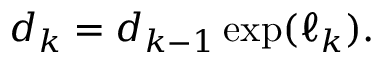Convert formula to latex. <formula><loc_0><loc_0><loc_500><loc_500>d _ { k } = d _ { k - 1 } \exp ( \ell _ { k } ) .</formula> 